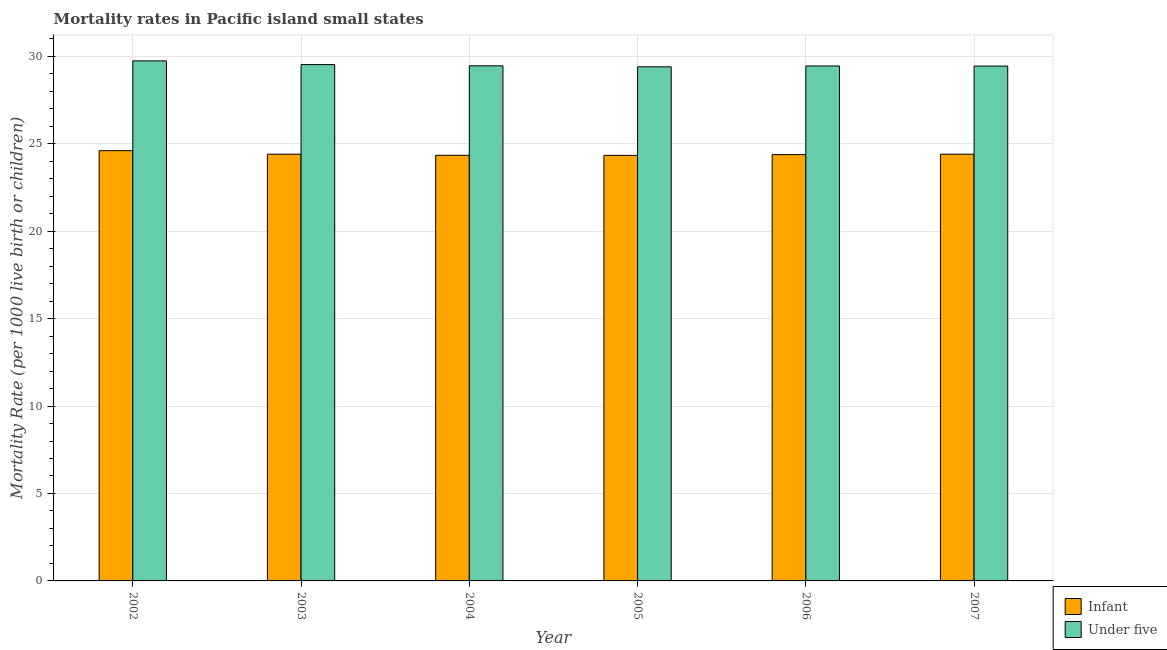How many groups of bars are there?
Your response must be concise. 6. What is the label of the 4th group of bars from the left?
Offer a terse response. 2005. What is the under-5 mortality rate in 2006?
Make the answer very short. 29.44. Across all years, what is the maximum infant mortality rate?
Offer a very short reply. 24.6. Across all years, what is the minimum infant mortality rate?
Make the answer very short. 24.33. What is the total under-5 mortality rate in the graph?
Your answer should be very brief. 176.99. What is the difference between the under-5 mortality rate in 2002 and that in 2006?
Make the answer very short. 0.29. What is the difference between the infant mortality rate in 2003 and the under-5 mortality rate in 2004?
Keep it short and to the point. 0.06. What is the average under-5 mortality rate per year?
Offer a very short reply. 29.5. What is the ratio of the infant mortality rate in 2003 to that in 2007?
Give a very brief answer. 1. Is the infant mortality rate in 2004 less than that in 2006?
Give a very brief answer. Yes. Is the difference between the infant mortality rate in 2004 and 2005 greater than the difference between the under-5 mortality rate in 2004 and 2005?
Give a very brief answer. No. What is the difference between the highest and the second highest under-5 mortality rate?
Make the answer very short. 0.21. What is the difference between the highest and the lowest under-5 mortality rate?
Keep it short and to the point. 0.34. In how many years, is the under-5 mortality rate greater than the average under-5 mortality rate taken over all years?
Your response must be concise. 2. What does the 1st bar from the left in 2005 represents?
Ensure brevity in your answer.  Infant. What does the 1st bar from the right in 2004 represents?
Give a very brief answer. Under five. How many bars are there?
Give a very brief answer. 12. Are all the bars in the graph horizontal?
Give a very brief answer. No. What is the difference between two consecutive major ticks on the Y-axis?
Give a very brief answer. 5. Does the graph contain any zero values?
Your answer should be compact. No. How many legend labels are there?
Offer a very short reply. 2. What is the title of the graph?
Make the answer very short. Mortality rates in Pacific island small states. Does "Stunting" appear as one of the legend labels in the graph?
Provide a succinct answer. No. What is the label or title of the X-axis?
Your response must be concise. Year. What is the label or title of the Y-axis?
Ensure brevity in your answer.  Mortality Rate (per 1000 live birth or children). What is the Mortality Rate (per 1000 live birth or children) of Infant in 2002?
Give a very brief answer. 24.6. What is the Mortality Rate (per 1000 live birth or children) in Under five in 2002?
Your response must be concise. 29.74. What is the Mortality Rate (per 1000 live birth or children) in Infant in 2003?
Provide a succinct answer. 24.4. What is the Mortality Rate (per 1000 live birth or children) of Under five in 2003?
Keep it short and to the point. 29.52. What is the Mortality Rate (per 1000 live birth or children) in Infant in 2004?
Offer a terse response. 24.34. What is the Mortality Rate (per 1000 live birth or children) of Under five in 2004?
Keep it short and to the point. 29.45. What is the Mortality Rate (per 1000 live birth or children) in Infant in 2005?
Your response must be concise. 24.33. What is the Mortality Rate (per 1000 live birth or children) of Under five in 2005?
Offer a terse response. 29.4. What is the Mortality Rate (per 1000 live birth or children) of Infant in 2006?
Give a very brief answer. 24.38. What is the Mortality Rate (per 1000 live birth or children) of Under five in 2006?
Offer a terse response. 29.44. What is the Mortality Rate (per 1000 live birth or children) of Infant in 2007?
Ensure brevity in your answer.  24.4. What is the Mortality Rate (per 1000 live birth or children) of Under five in 2007?
Offer a terse response. 29.44. Across all years, what is the maximum Mortality Rate (per 1000 live birth or children) of Infant?
Your answer should be compact. 24.6. Across all years, what is the maximum Mortality Rate (per 1000 live birth or children) in Under five?
Your answer should be very brief. 29.74. Across all years, what is the minimum Mortality Rate (per 1000 live birth or children) in Infant?
Your answer should be very brief. 24.33. Across all years, what is the minimum Mortality Rate (per 1000 live birth or children) of Under five?
Offer a very short reply. 29.4. What is the total Mortality Rate (per 1000 live birth or children) of Infant in the graph?
Give a very brief answer. 146.45. What is the total Mortality Rate (per 1000 live birth or children) of Under five in the graph?
Your answer should be compact. 176.99. What is the difference between the Mortality Rate (per 1000 live birth or children) of Infant in 2002 and that in 2003?
Your answer should be very brief. 0.2. What is the difference between the Mortality Rate (per 1000 live birth or children) in Under five in 2002 and that in 2003?
Your answer should be compact. 0.21. What is the difference between the Mortality Rate (per 1000 live birth or children) in Infant in 2002 and that in 2004?
Your answer should be compact. 0.26. What is the difference between the Mortality Rate (per 1000 live birth or children) of Under five in 2002 and that in 2004?
Offer a very short reply. 0.28. What is the difference between the Mortality Rate (per 1000 live birth or children) in Infant in 2002 and that in 2005?
Offer a terse response. 0.27. What is the difference between the Mortality Rate (per 1000 live birth or children) in Under five in 2002 and that in 2005?
Provide a short and direct response. 0.34. What is the difference between the Mortality Rate (per 1000 live birth or children) of Infant in 2002 and that in 2006?
Offer a terse response. 0.22. What is the difference between the Mortality Rate (per 1000 live birth or children) of Under five in 2002 and that in 2006?
Keep it short and to the point. 0.29. What is the difference between the Mortality Rate (per 1000 live birth or children) of Infant in 2002 and that in 2007?
Your answer should be very brief. 0.2. What is the difference between the Mortality Rate (per 1000 live birth or children) of Under five in 2002 and that in 2007?
Ensure brevity in your answer.  0.3. What is the difference between the Mortality Rate (per 1000 live birth or children) in Infant in 2003 and that in 2004?
Provide a short and direct response. 0.06. What is the difference between the Mortality Rate (per 1000 live birth or children) of Under five in 2003 and that in 2004?
Your answer should be very brief. 0.07. What is the difference between the Mortality Rate (per 1000 live birth or children) in Infant in 2003 and that in 2005?
Offer a terse response. 0.07. What is the difference between the Mortality Rate (per 1000 live birth or children) of Under five in 2003 and that in 2005?
Ensure brevity in your answer.  0.13. What is the difference between the Mortality Rate (per 1000 live birth or children) of Infant in 2003 and that in 2006?
Keep it short and to the point. 0.02. What is the difference between the Mortality Rate (per 1000 live birth or children) in Under five in 2003 and that in 2006?
Provide a succinct answer. 0.08. What is the difference between the Mortality Rate (per 1000 live birth or children) in Infant in 2003 and that in 2007?
Your answer should be compact. 0. What is the difference between the Mortality Rate (per 1000 live birth or children) of Under five in 2003 and that in 2007?
Make the answer very short. 0.08. What is the difference between the Mortality Rate (per 1000 live birth or children) of Infant in 2004 and that in 2005?
Offer a very short reply. 0. What is the difference between the Mortality Rate (per 1000 live birth or children) in Under five in 2004 and that in 2005?
Your answer should be very brief. 0.06. What is the difference between the Mortality Rate (per 1000 live birth or children) of Infant in 2004 and that in 2006?
Your answer should be very brief. -0.04. What is the difference between the Mortality Rate (per 1000 live birth or children) of Under five in 2004 and that in 2006?
Provide a short and direct response. 0.01. What is the difference between the Mortality Rate (per 1000 live birth or children) in Infant in 2004 and that in 2007?
Give a very brief answer. -0.06. What is the difference between the Mortality Rate (per 1000 live birth or children) in Under five in 2004 and that in 2007?
Your answer should be very brief. 0.01. What is the difference between the Mortality Rate (per 1000 live birth or children) in Infant in 2005 and that in 2006?
Provide a succinct answer. -0.04. What is the difference between the Mortality Rate (per 1000 live birth or children) in Under five in 2005 and that in 2006?
Offer a terse response. -0.05. What is the difference between the Mortality Rate (per 1000 live birth or children) of Infant in 2005 and that in 2007?
Your answer should be compact. -0.07. What is the difference between the Mortality Rate (per 1000 live birth or children) of Under five in 2005 and that in 2007?
Provide a short and direct response. -0.04. What is the difference between the Mortality Rate (per 1000 live birth or children) of Infant in 2006 and that in 2007?
Your response must be concise. -0.02. What is the difference between the Mortality Rate (per 1000 live birth or children) in Under five in 2006 and that in 2007?
Keep it short and to the point. 0. What is the difference between the Mortality Rate (per 1000 live birth or children) of Infant in 2002 and the Mortality Rate (per 1000 live birth or children) of Under five in 2003?
Ensure brevity in your answer.  -4.92. What is the difference between the Mortality Rate (per 1000 live birth or children) of Infant in 2002 and the Mortality Rate (per 1000 live birth or children) of Under five in 2004?
Your response must be concise. -4.85. What is the difference between the Mortality Rate (per 1000 live birth or children) of Infant in 2002 and the Mortality Rate (per 1000 live birth or children) of Under five in 2005?
Your answer should be compact. -4.79. What is the difference between the Mortality Rate (per 1000 live birth or children) in Infant in 2002 and the Mortality Rate (per 1000 live birth or children) in Under five in 2006?
Offer a terse response. -4.84. What is the difference between the Mortality Rate (per 1000 live birth or children) of Infant in 2002 and the Mortality Rate (per 1000 live birth or children) of Under five in 2007?
Keep it short and to the point. -4.84. What is the difference between the Mortality Rate (per 1000 live birth or children) of Infant in 2003 and the Mortality Rate (per 1000 live birth or children) of Under five in 2004?
Make the answer very short. -5.05. What is the difference between the Mortality Rate (per 1000 live birth or children) in Infant in 2003 and the Mortality Rate (per 1000 live birth or children) in Under five in 2005?
Keep it short and to the point. -5. What is the difference between the Mortality Rate (per 1000 live birth or children) in Infant in 2003 and the Mortality Rate (per 1000 live birth or children) in Under five in 2006?
Your response must be concise. -5.04. What is the difference between the Mortality Rate (per 1000 live birth or children) in Infant in 2003 and the Mortality Rate (per 1000 live birth or children) in Under five in 2007?
Provide a succinct answer. -5.04. What is the difference between the Mortality Rate (per 1000 live birth or children) in Infant in 2004 and the Mortality Rate (per 1000 live birth or children) in Under five in 2005?
Make the answer very short. -5.06. What is the difference between the Mortality Rate (per 1000 live birth or children) of Infant in 2004 and the Mortality Rate (per 1000 live birth or children) of Under five in 2006?
Offer a very short reply. -5.11. What is the difference between the Mortality Rate (per 1000 live birth or children) of Infant in 2004 and the Mortality Rate (per 1000 live birth or children) of Under five in 2007?
Your answer should be very brief. -5.1. What is the difference between the Mortality Rate (per 1000 live birth or children) of Infant in 2005 and the Mortality Rate (per 1000 live birth or children) of Under five in 2006?
Make the answer very short. -5.11. What is the difference between the Mortality Rate (per 1000 live birth or children) in Infant in 2005 and the Mortality Rate (per 1000 live birth or children) in Under five in 2007?
Offer a terse response. -5.11. What is the difference between the Mortality Rate (per 1000 live birth or children) of Infant in 2006 and the Mortality Rate (per 1000 live birth or children) of Under five in 2007?
Provide a succinct answer. -5.06. What is the average Mortality Rate (per 1000 live birth or children) in Infant per year?
Ensure brevity in your answer.  24.41. What is the average Mortality Rate (per 1000 live birth or children) in Under five per year?
Provide a succinct answer. 29.5. In the year 2002, what is the difference between the Mortality Rate (per 1000 live birth or children) of Infant and Mortality Rate (per 1000 live birth or children) of Under five?
Provide a succinct answer. -5.13. In the year 2003, what is the difference between the Mortality Rate (per 1000 live birth or children) of Infant and Mortality Rate (per 1000 live birth or children) of Under five?
Provide a short and direct response. -5.12. In the year 2004, what is the difference between the Mortality Rate (per 1000 live birth or children) in Infant and Mortality Rate (per 1000 live birth or children) in Under five?
Offer a very short reply. -5.12. In the year 2005, what is the difference between the Mortality Rate (per 1000 live birth or children) of Infant and Mortality Rate (per 1000 live birth or children) of Under five?
Make the answer very short. -5.06. In the year 2006, what is the difference between the Mortality Rate (per 1000 live birth or children) in Infant and Mortality Rate (per 1000 live birth or children) in Under five?
Ensure brevity in your answer.  -5.07. In the year 2007, what is the difference between the Mortality Rate (per 1000 live birth or children) of Infant and Mortality Rate (per 1000 live birth or children) of Under five?
Your answer should be compact. -5.04. What is the ratio of the Mortality Rate (per 1000 live birth or children) in Infant in 2002 to that in 2003?
Keep it short and to the point. 1.01. What is the ratio of the Mortality Rate (per 1000 live birth or children) in Under five in 2002 to that in 2003?
Your answer should be compact. 1.01. What is the ratio of the Mortality Rate (per 1000 live birth or children) in Infant in 2002 to that in 2004?
Ensure brevity in your answer.  1.01. What is the ratio of the Mortality Rate (per 1000 live birth or children) in Under five in 2002 to that in 2004?
Your answer should be very brief. 1.01. What is the ratio of the Mortality Rate (per 1000 live birth or children) of Infant in 2002 to that in 2005?
Give a very brief answer. 1.01. What is the ratio of the Mortality Rate (per 1000 live birth or children) of Under five in 2002 to that in 2005?
Your answer should be compact. 1.01. What is the ratio of the Mortality Rate (per 1000 live birth or children) of Infant in 2002 to that in 2006?
Make the answer very short. 1.01. What is the ratio of the Mortality Rate (per 1000 live birth or children) of Under five in 2002 to that in 2006?
Provide a succinct answer. 1.01. What is the ratio of the Mortality Rate (per 1000 live birth or children) of Infant in 2002 to that in 2007?
Make the answer very short. 1.01. What is the ratio of the Mortality Rate (per 1000 live birth or children) in Under five in 2003 to that in 2004?
Keep it short and to the point. 1. What is the ratio of the Mortality Rate (per 1000 live birth or children) of Infant in 2003 to that in 2005?
Provide a short and direct response. 1. What is the ratio of the Mortality Rate (per 1000 live birth or children) of Under five in 2003 to that in 2005?
Make the answer very short. 1. What is the ratio of the Mortality Rate (per 1000 live birth or children) in Under five in 2003 to that in 2006?
Ensure brevity in your answer.  1. What is the ratio of the Mortality Rate (per 1000 live birth or children) of Under five in 2003 to that in 2007?
Provide a succinct answer. 1. What is the ratio of the Mortality Rate (per 1000 live birth or children) in Under five in 2004 to that in 2005?
Give a very brief answer. 1. What is the ratio of the Mortality Rate (per 1000 live birth or children) in Infant in 2004 to that in 2006?
Your response must be concise. 1. What is the ratio of the Mortality Rate (per 1000 live birth or children) of Under five in 2004 to that in 2006?
Offer a terse response. 1. What is the ratio of the Mortality Rate (per 1000 live birth or children) of Under five in 2004 to that in 2007?
Give a very brief answer. 1. What is the ratio of the Mortality Rate (per 1000 live birth or children) of Infant in 2005 to that in 2006?
Your response must be concise. 1. What is the ratio of the Mortality Rate (per 1000 live birth or children) in Infant in 2006 to that in 2007?
Your response must be concise. 1. What is the ratio of the Mortality Rate (per 1000 live birth or children) of Under five in 2006 to that in 2007?
Offer a very short reply. 1. What is the difference between the highest and the second highest Mortality Rate (per 1000 live birth or children) of Infant?
Provide a succinct answer. 0.2. What is the difference between the highest and the second highest Mortality Rate (per 1000 live birth or children) of Under five?
Offer a terse response. 0.21. What is the difference between the highest and the lowest Mortality Rate (per 1000 live birth or children) of Infant?
Keep it short and to the point. 0.27. What is the difference between the highest and the lowest Mortality Rate (per 1000 live birth or children) in Under five?
Make the answer very short. 0.34. 